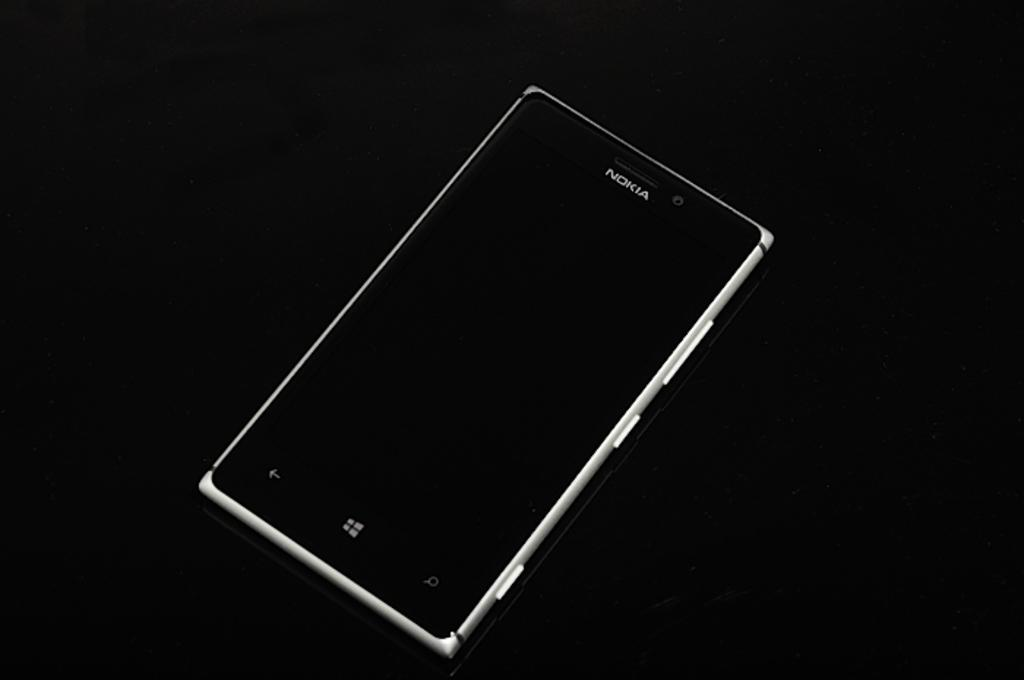<image>
Share a concise interpretation of the image provided. A Nokia cell phone is resting a black background. 